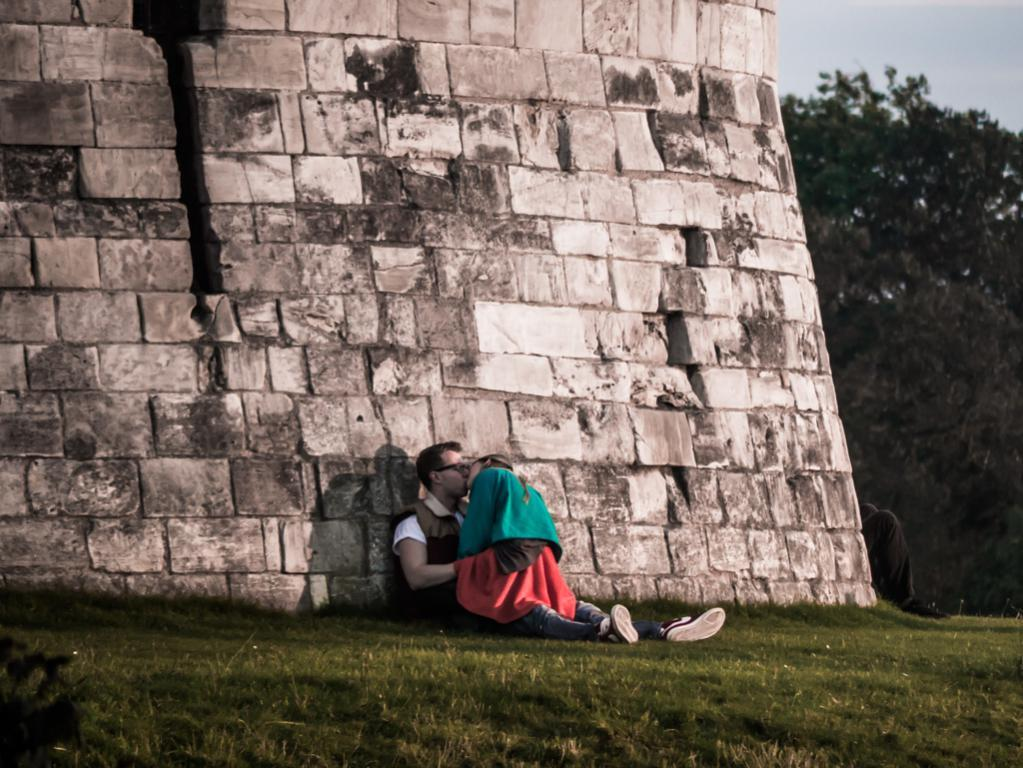What are the two persons in the image doing? The two persons in the image are kissing. What type of natural environment is visible in the image? There is grass visible in the image, and there are trees and the sky in the background. What can be seen in the background of the image? There is a wall, trees, and the sky visible in the background of the image. What type of cabbage is being used as a hat in the image? There is no cabbage present in the image, let alone being used as a hat. What type of suit is the person wearing in the image? There is no suit visible in the image; the two persons are dressed casually. 